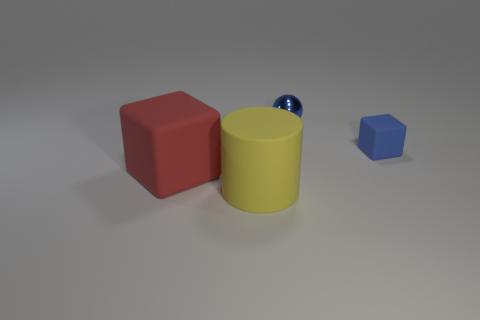The red thing that is the same size as the yellow rubber object is what shape?
Provide a succinct answer. Cube. What number of small objects are either rubber blocks or blue things?
Provide a succinct answer. 2. There is a blue object to the left of the blue object in front of the tiny ball; are there any yellow rubber cylinders on the right side of it?
Offer a terse response. No. Is there a red ball of the same size as the shiny thing?
Make the answer very short. No. What is the material of the cube that is the same size as the rubber cylinder?
Keep it short and to the point. Rubber. There is a blue matte block; does it have the same size as the rubber cube that is on the left side of the blue ball?
Keep it short and to the point. No. What number of metal things are either large objects or green cylinders?
Keep it short and to the point. 0. What number of other matte objects are the same shape as the tiny blue rubber object?
Your answer should be very brief. 1. There is a object that is the same color as the tiny metal ball; what is its material?
Make the answer very short. Rubber. Do the red matte block to the left of the shiny sphere and the matte object that is on the right side of the yellow matte cylinder have the same size?
Provide a short and direct response. No. 